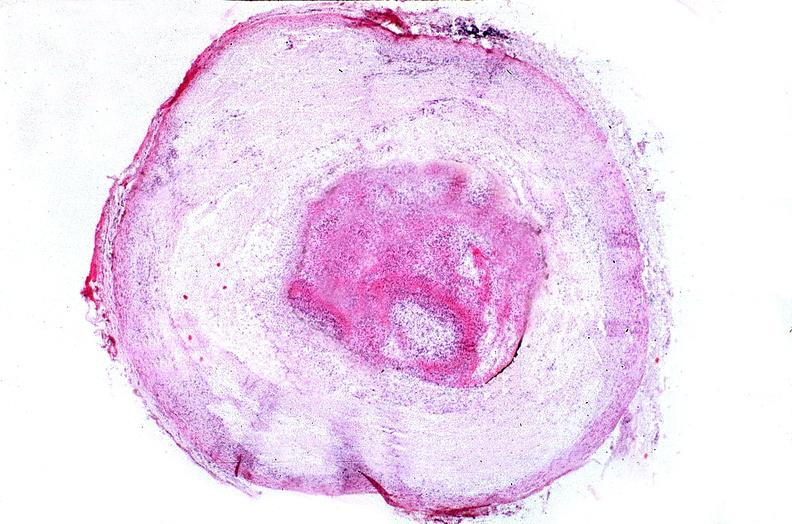s mesentery present?
Answer the question using a single word or phrase. No 